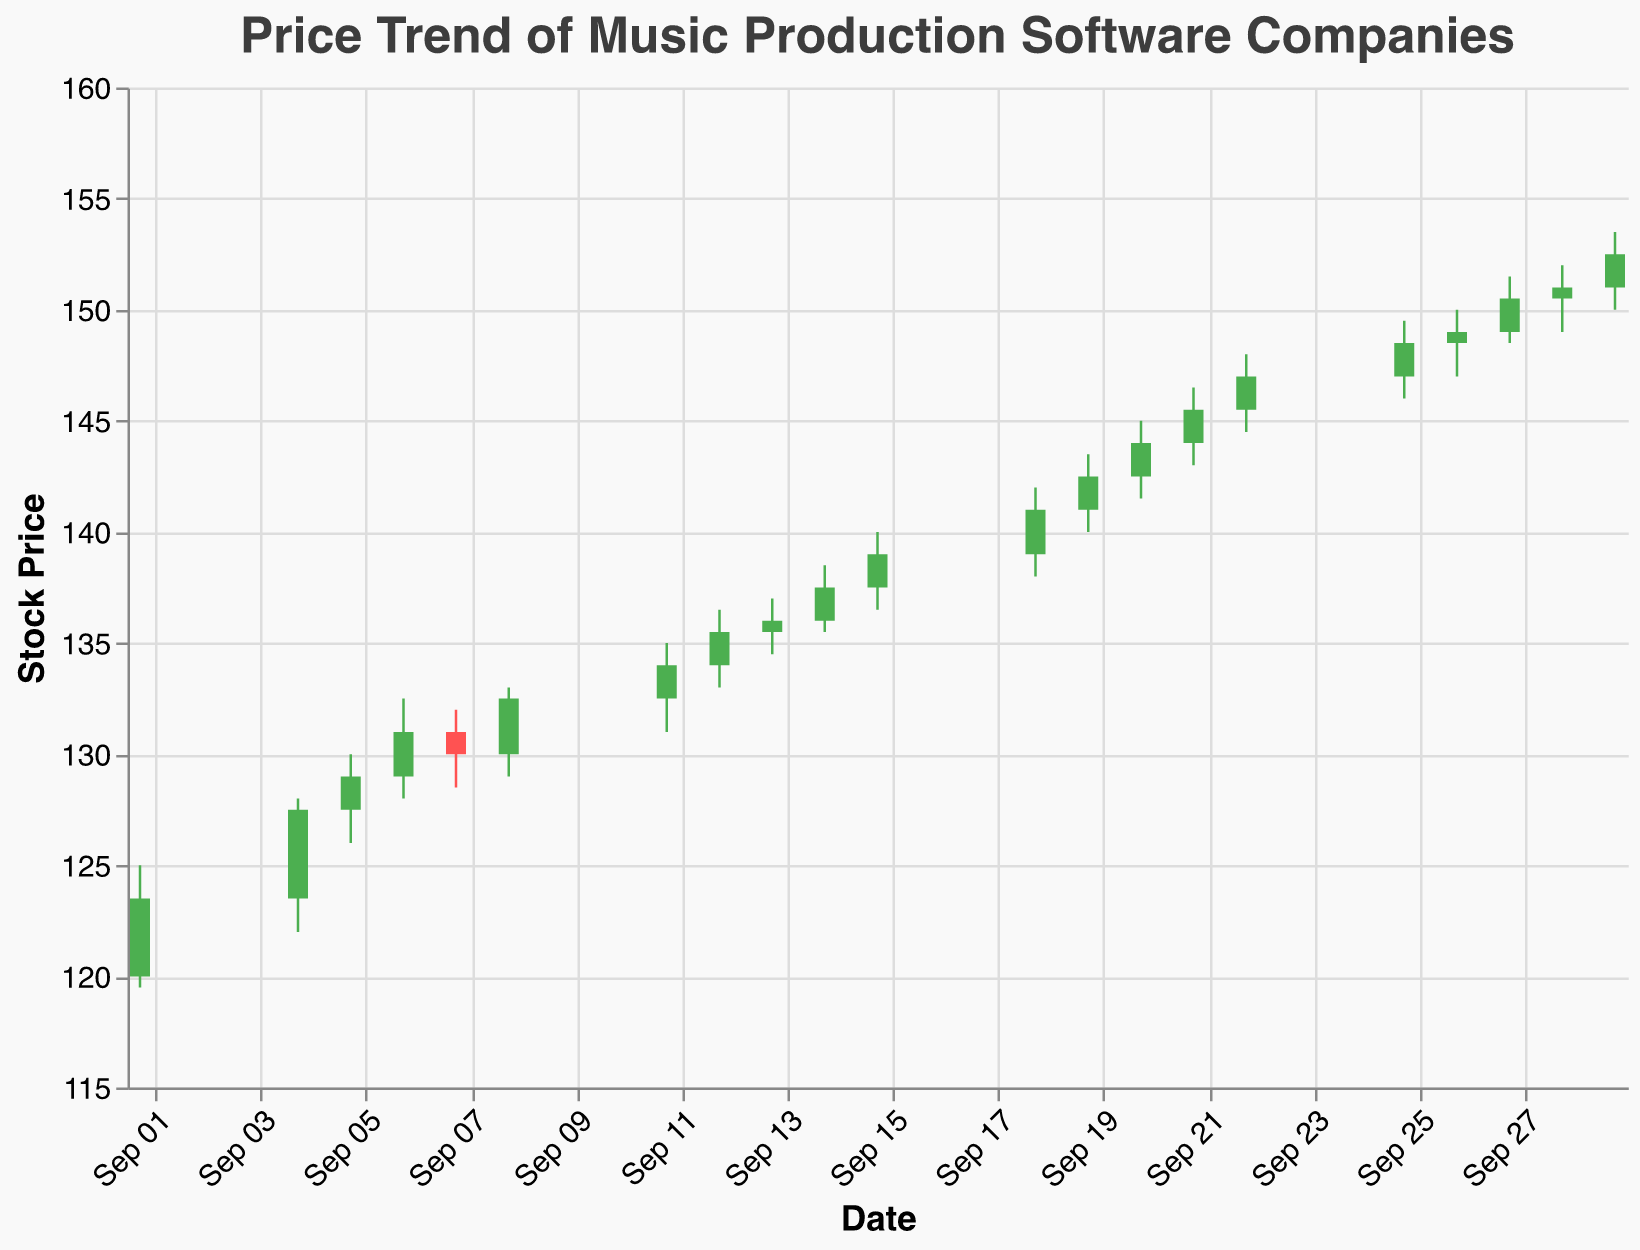What is the title of the figure? The title is displayed at the top of the figure and it reads "Price Trend of Music Production Software Companies".
Answer: Price Trend of Music Production Software Companies Between which dates does the data range? By looking at the x-axis, which represents the date, the data ranges from the starting date of September 1st, 2023 to the ending date of September 29th, 2023.
Answer: September 1st, 2023 to September 29th, 2023 How many data points are there in total? Counting the number of candlesticks present in the figure, each representing a trading day, there are 20 data points in total.
Answer: 20 What was the highest closing price observed in September 2023? The highest closing price can be deducted by looking for the highest point where the candlestick bodies (or bars) end. The highest observed closing price is on September 29th with $152.5.
Answer: $152.5 Which date saw the highest trading volume, and what was that volume? For each day, the vertical bar’s height indicates trading volume. By observing the figure closely, the highest trading volume occurred on September 29th, with a volume of 59,000.
Answer: September 29th, 59,000 What was the closing price on September 15th, 2023? To find the closing price on a specific date, locate the candlestick for that date and see the top or bottom of the candlestick body. On September 15th, the closing price is $139.00.
Answer: $139.00 On which days did the closing price remain higher than the opening price? For this, identify the days with green candlesticks, where the closing price (top of the body) is higher than the opening price (bottom of the body). These days are September 1st, 4th, 5th, 6th, 8th, 11th, 12th, 14th, 15th, 18th, and 19th.
Answer: September 1st, 4th, 5th, 6th, 8th, 11th, 12th, 14th, 15th, 18th, and 19th What is the average closing price during this period? Sum all the closing prices (123.5 + 127.5 + 129.0 + 131.0 + 130.0 + 132.5 + 134.0 + 135.5 + 136.0 + 137.5 + 139.0 + 141.0 + 142.5 + 144.0 + 145.5 + 147.0 + 148.5 + 149.0 + 150.5 + 152.5) and divide by the number of data points (20). The calculated average is 138.8.
Answer: 138.8 What was the lowest price on September 13th, 2023, and how does it compare to the highest price on the same day? On September 13th, find the lowest and the highest points of the candlestick. The lowest price was $134.5 and the highest was $137.0.
Answer: $134.5 (lowest), $137.0 (highest) How did the stock price trend in September 2023 for music production software companies? Over the entire period, the closing prices generally increased, starting from an initial closing price of $123.5 on September 1st and closing at $152.5 on September 29th, which shows an overall upward price trend.
Answer: Upward trend 